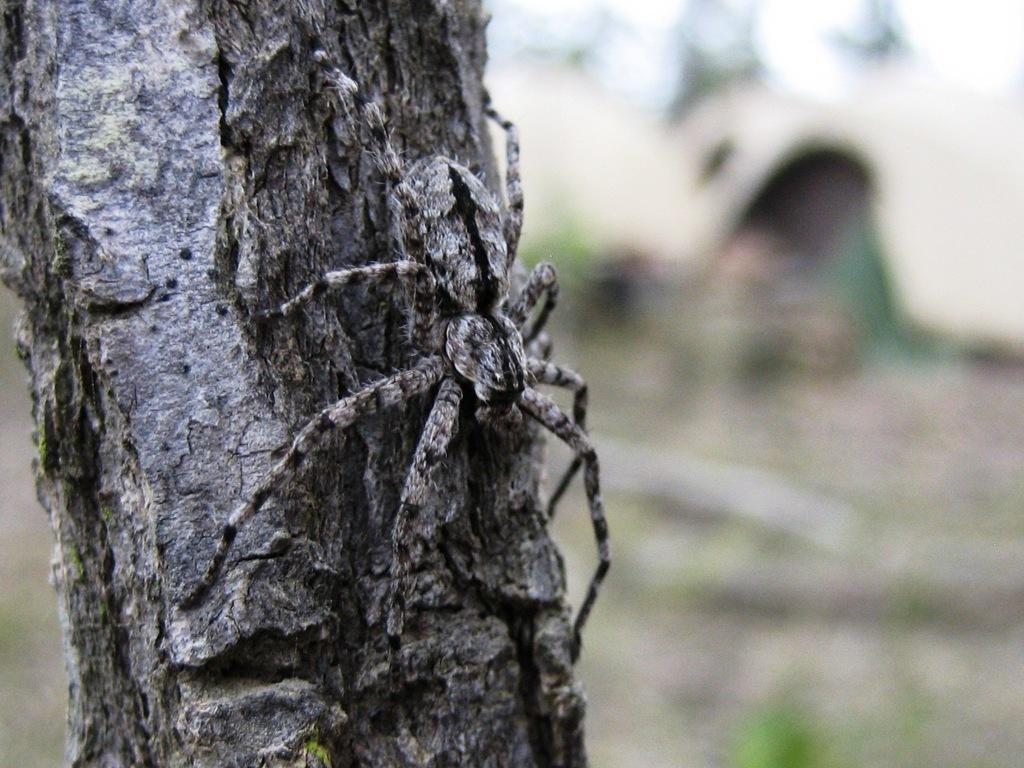What is the main subject of the image? There is a spider in the image. Where is the spider located? The spider is on a stem. Can you describe the background of the image? The background of the image is blurred. How does the spider kick the ball in the image? There is no ball present in the image, and spiders do not kick objects like balls. 